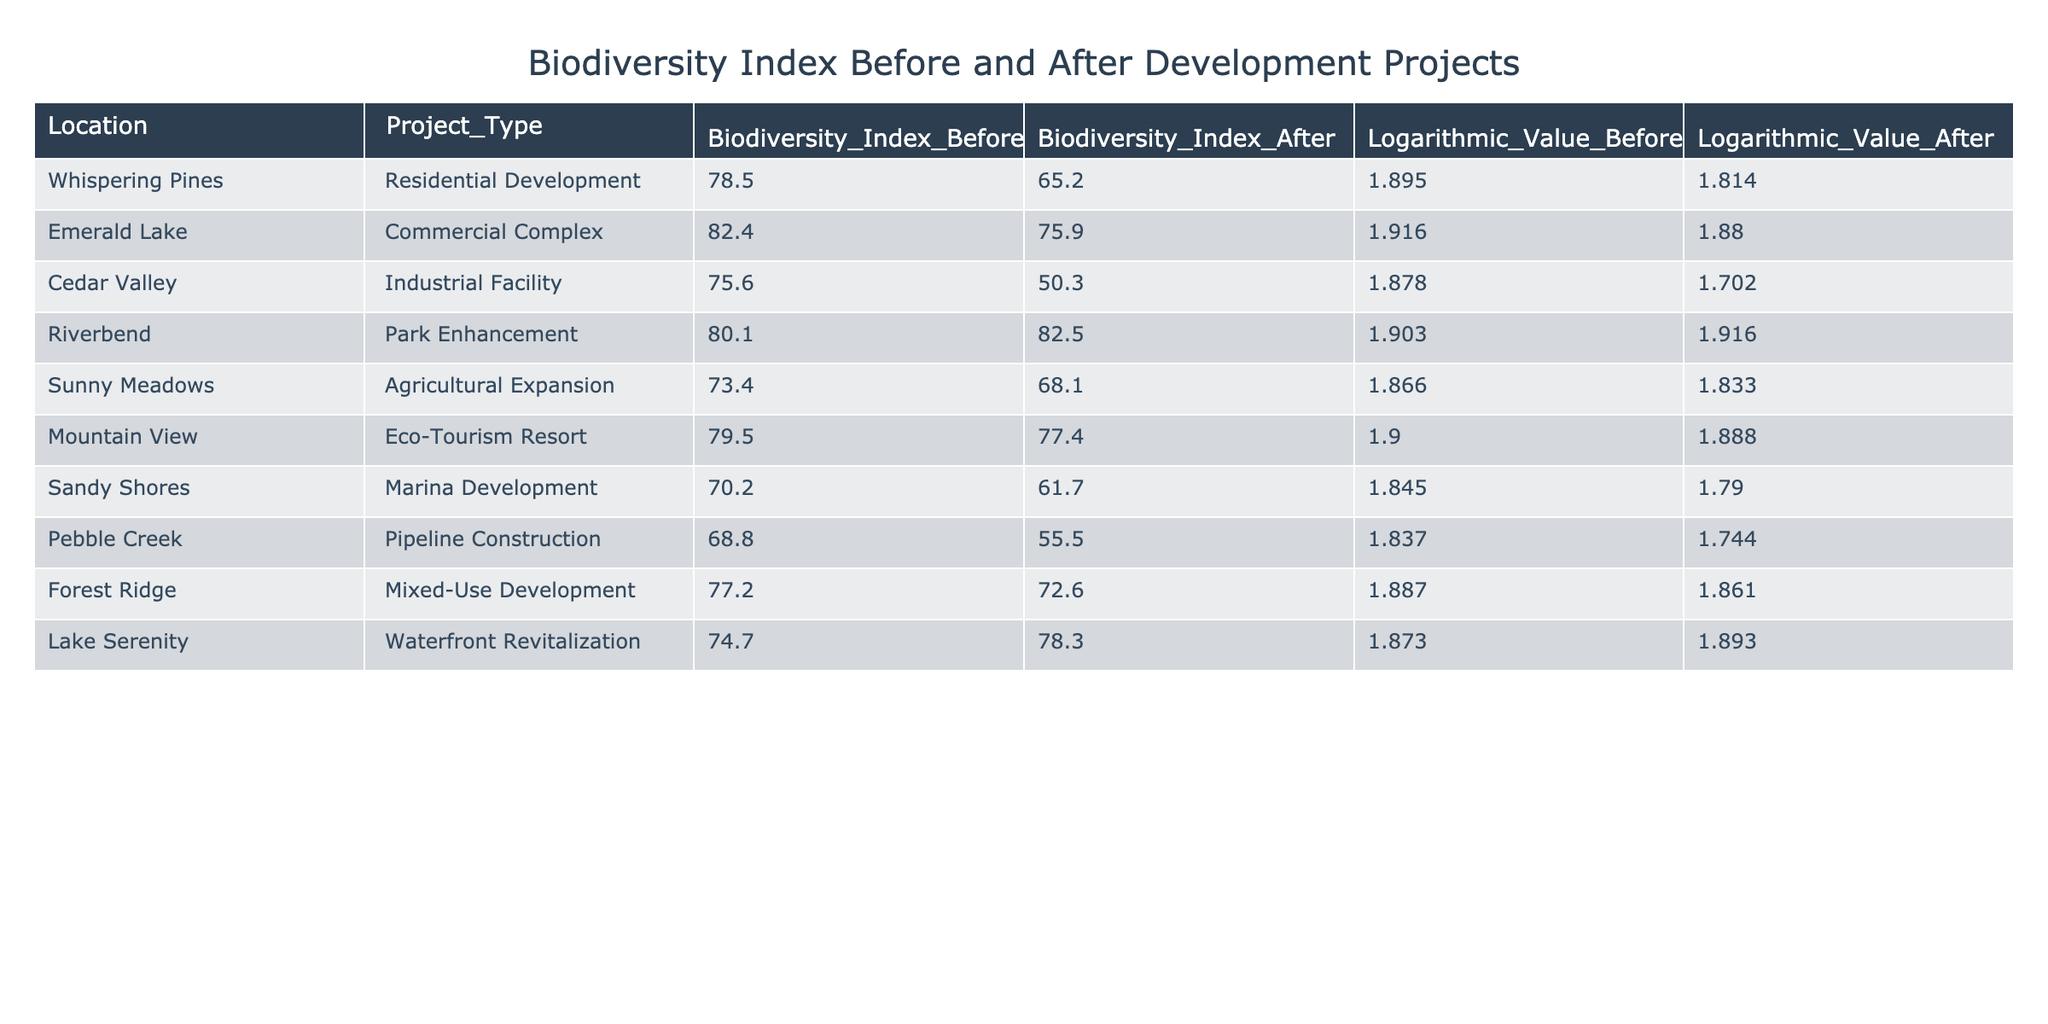What was the Biodiversity Index Before the Residential Development project in Whispering Pines? The table indicates that the Biodiversity Index Before the Residential Development project in Whispering Pines was 78.5.
Answer: 78.5 What is the difference in the Biodiversity Index After and Before the Industrial Facility project in Cedar Valley? The Biodiversity Index Before the Industrial Facility project was 75.6, and After it was 50.3. The difference is 75.6 - 50.3 = 25.3.
Answer: 25.3 Is the Biodiversity Index After the Park Enhancement project in Riverbend higher than it was Before the project? The Biodiversity Index Before the Park Enhancement project was 80.1 and After it was 82.5. Since 82.5 is greater than 80.1, the statement is true.
Answer: Yes What is the average Biodiversity Index Before the development projects listed? To find the average, sum the indices: 78.5 + 82.4 + 75.6 + 80.1 + 73.4 + 79.5 + 70.2 + 68.8 + 77.2 + 74.7 = 78.10, then divide by 10 (the number of projects), so 78.10 / 10 = 78.10.
Answer: 78.10 Which project resulted in the highest decrease in the Biodiversity Index? Comparing the decreases: Residential Development: 78.5 - 65.2 = 13.3, Commercial Complex: 82.4 - 75.9 = 6.5, Industrial Facility: 75.6 - 50.3 = 25.3, Park Enhancement: 80.1 - 82.5 = -2.4 (increase), Agricultural Expansion: 73.4 - 68.1 = 5.3, Eco-Tourism Resort: 79.5 - 77.4 = 2.1, Marina Development: 70.2 - 61.7 = 8.5, Pipeline Construction: 68.8 - 55.5 = 13.3, Mixed-Use Development: 77.2 - 72.6 = 4.6, Waterfront Revitalization: 74.7 - 78.3 = -3.6 (increase). The Industrial Facility has the highest decrease of 25.3.
Answer: Industrial Facility 